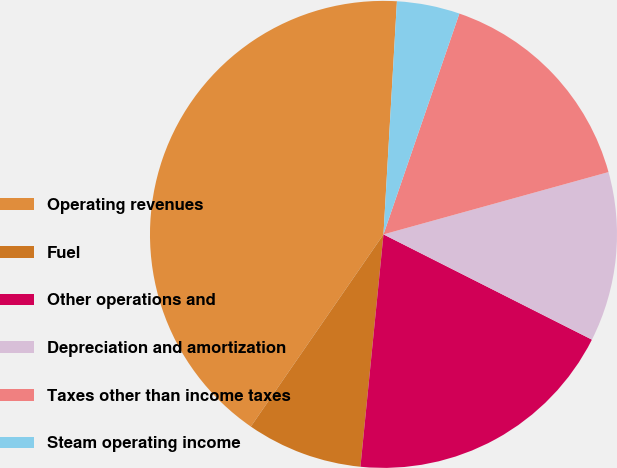<chart> <loc_0><loc_0><loc_500><loc_500><pie_chart><fcel>Operating revenues<fcel>Fuel<fcel>Other operations and<fcel>Depreciation and amortization<fcel>Taxes other than income taxes<fcel>Steam operating income<nl><fcel>41.3%<fcel>8.04%<fcel>19.13%<fcel>11.74%<fcel>15.43%<fcel>4.35%<nl></chart> 